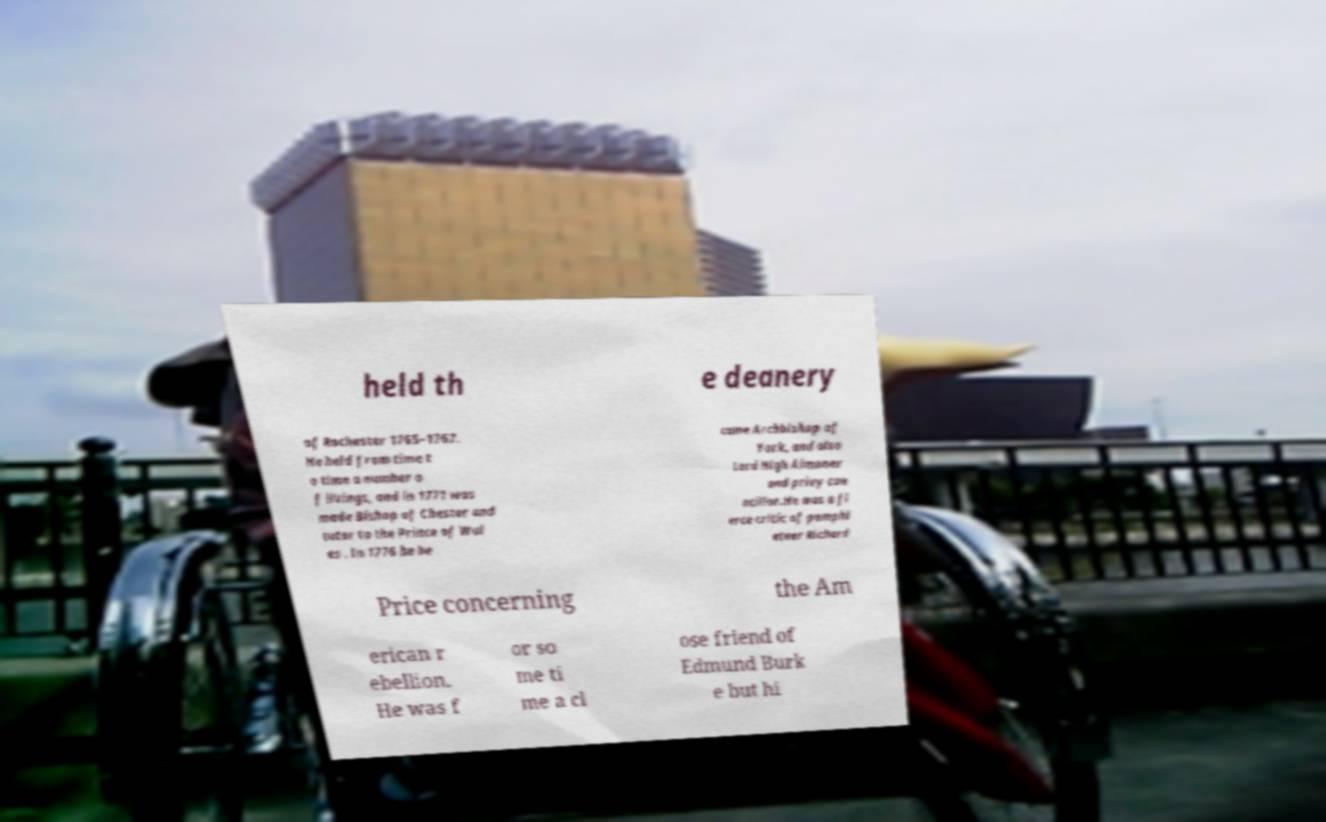I need the written content from this picture converted into text. Can you do that? held th e deanery of Rochester 1765–1767. He held from time t o time a number o f livings, and in 1771 was made Bishop of Chester and tutor to the Prince of Wal es . In 1776 he be came Archbishop of York, and also Lord High Almoner and privy cou ncillor.He was a fi erce critic of pamphl eteer Richard Price concerning the Am erican r ebellion. He was f or so me ti me a cl ose friend of Edmund Burk e but hi 